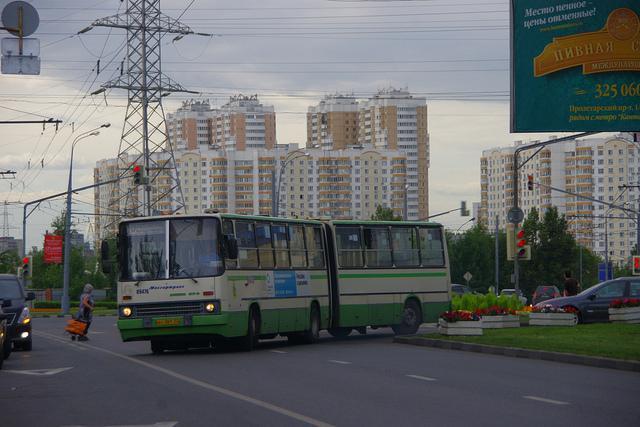What is the woman trying to do?
Answer the question by selecting the correct answer among the 4 following choices.
Options: Cross street, board bus, board car, jog. Cross street. 